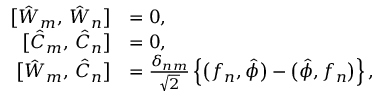<formula> <loc_0><loc_0><loc_500><loc_500>\begin{array} { r l } { \left [ \hat { W } _ { m } , \, \hat { W } _ { n } \right ] } & { = 0 , } \\ { \left [ \hat { C } _ { m } , \, \hat { C } _ { n } \right ] } & { = 0 , } \\ { \left [ \hat { W } _ { m } , \, \hat { C } _ { n } \right ] } & { = \frac { \delta _ { n m } } { \sqrt { 2 } } \left \{ \left ( f _ { n } , \hat { \phi } \right ) - \left ( \hat { \phi } , f _ { n } \right ) \right \} , } \end{array}</formula> 